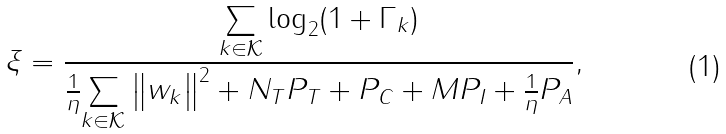Convert formula to latex. <formula><loc_0><loc_0><loc_500><loc_500>\xi = \frac { \underset { k \in \mathcal { K } } { \sum } \log _ { 2 } ( 1 + \Gamma _ { k } ) } { \frac { 1 } { \eta } \underset { k \in \mathcal { K } } { \sum } \left \| w _ { k } \right \| ^ { 2 } + N _ { T } P _ { T } + P _ { C } + M P _ { I } + \frac { 1 } { \eta } P _ { A } } ,</formula> 